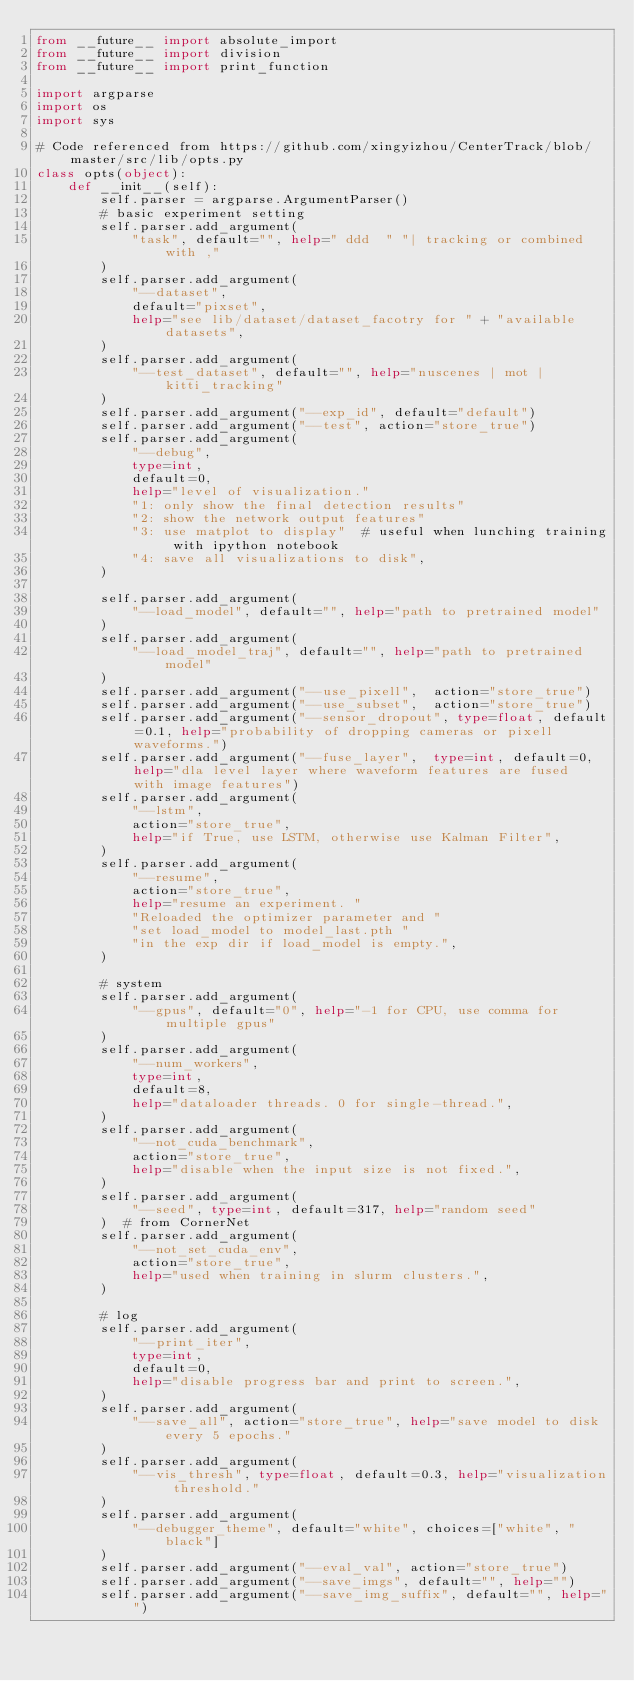Convert code to text. <code><loc_0><loc_0><loc_500><loc_500><_Python_>from __future__ import absolute_import
from __future__ import division
from __future__ import print_function

import argparse
import os
import sys

# Code referenced from https://github.com/xingyizhou/CenterTrack/blob/master/src/lib/opts.py
class opts(object):
    def __init__(self):
        self.parser = argparse.ArgumentParser()
        # basic experiment setting
        self.parser.add_argument(
            "task", default="", help=" ddd  " "| tracking or combined with ,"
        )
        self.parser.add_argument(
            "--dataset",
            default="pixset",
            help="see lib/dataset/dataset_facotry for " + "available datasets",
        )
        self.parser.add_argument(
            "--test_dataset", default="", help="nuscenes | mot | kitti_tracking"
        )
        self.parser.add_argument("--exp_id", default="default")
        self.parser.add_argument("--test", action="store_true")
        self.parser.add_argument(
            "--debug",
            type=int,
            default=0,
            help="level of visualization."
            "1: only show the final detection results"
            "2: show the network output features"
            "3: use matplot to display"  # useful when lunching training with ipython notebook
            "4: save all visualizations to disk",
        )

        self.parser.add_argument(
            "--load_model", default="", help="path to pretrained model"
        )
        self.parser.add_argument(
            "--load_model_traj", default="", help="path to pretrained model"
        )
        self.parser.add_argument("--use_pixell",  action="store_true")
        self.parser.add_argument("--use_subset",  action="store_true")
        self.parser.add_argument("--sensor_dropout", type=float, default=0.1, help="probability of dropping cameras or pixell waveforms.")
        self.parser.add_argument("--fuse_layer",  type=int, default=0, help="dla level layer where waveform features are fused with image features")
        self.parser.add_argument(
            "--lstm",
            action="store_true",
            help="if True, use LSTM, otherwise use Kalman Filter",
        )
        self.parser.add_argument(
            "--resume",
            action="store_true",
            help="resume an experiment. "
            "Reloaded the optimizer parameter and "
            "set load_model to model_last.pth "
            "in the exp dir if load_model is empty.",
        )

        # system
        self.parser.add_argument(
            "--gpus", default="0", help="-1 for CPU, use comma for multiple gpus"
        )
        self.parser.add_argument(
            "--num_workers",
            type=int,
            default=8,
            help="dataloader threads. 0 for single-thread.",
        )
        self.parser.add_argument(
            "--not_cuda_benchmark",
            action="store_true",
            help="disable when the input size is not fixed.",
        )
        self.parser.add_argument(
            "--seed", type=int, default=317, help="random seed"
        )  # from CornerNet
        self.parser.add_argument(
            "--not_set_cuda_env",
            action="store_true",
            help="used when training in slurm clusters.",
        )

        # log
        self.parser.add_argument(
            "--print_iter",
            type=int,
            default=0,
            help="disable progress bar and print to screen.",
        )
        self.parser.add_argument(
            "--save_all", action="store_true", help="save model to disk every 5 epochs."
        )
        self.parser.add_argument(
            "--vis_thresh", type=float, default=0.3, help="visualization threshold."
        )
        self.parser.add_argument(
            "--debugger_theme", default="white", choices=["white", "black"]
        )
        self.parser.add_argument("--eval_val", action="store_true")
        self.parser.add_argument("--save_imgs", default="", help="")
        self.parser.add_argument("--save_img_suffix", default="", help="")</code> 